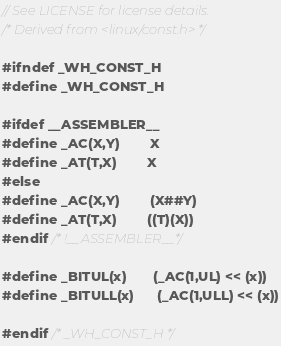Convert code to text. <code><loc_0><loc_0><loc_500><loc_500><_C_>// See LICENSE for license details.
/* Derived from <linux/const.h> */

#ifndef _WH_CONST_H
#define _WH_CONST_H

#ifdef __ASSEMBLER__
#define _AC(X,Y)        X
#define _AT(T,X)        X
#else
#define _AC(X,Y)        (X##Y)
#define _AT(T,X)        ((T)(X))
#endif /* !__ASSEMBLER__*/

#define _BITUL(x)       (_AC(1,UL) << (x))
#define _BITULL(x)      (_AC(1,ULL) << (x))

#endif /* _WH_CONST_H */
</code> 